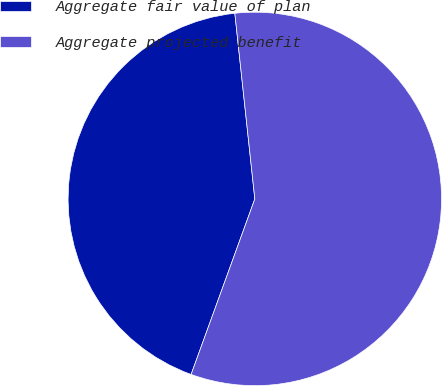Convert chart to OTSL. <chart><loc_0><loc_0><loc_500><loc_500><pie_chart><fcel>Aggregate fair value of plan<fcel>Aggregate projected benefit<nl><fcel>42.75%<fcel>57.25%<nl></chart> 